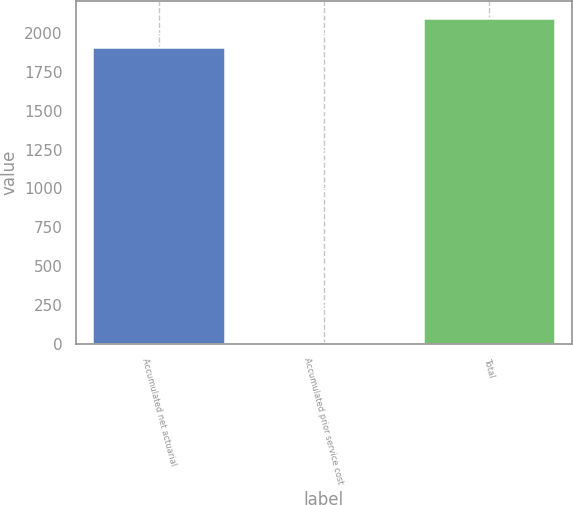Convert chart to OTSL. <chart><loc_0><loc_0><loc_500><loc_500><bar_chart><fcel>Accumulated net actuarial<fcel>Accumulated prior service cost<fcel>Total<nl><fcel>1911<fcel>1<fcel>2102.1<nl></chart> 